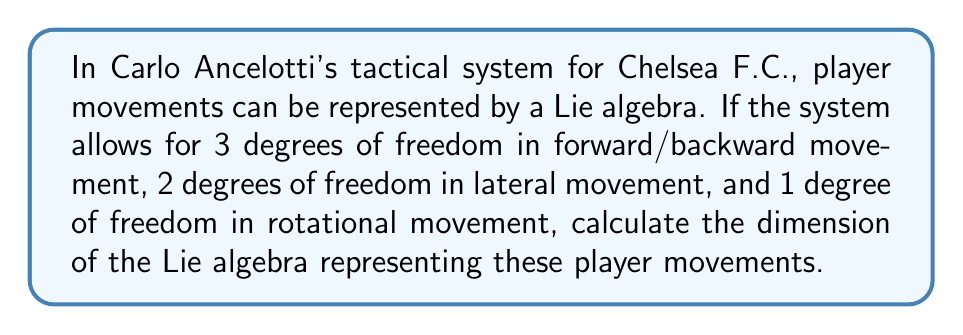Help me with this question. To solve this problem, we need to understand that the dimension of a Lie algebra is equal to the number of independent generators or basis elements. In this case, each degree of freedom corresponds to a generator in the Lie algebra.

Let's break down the degrees of freedom:

1. Forward/backward movement: 3 degrees of freedom
2. Lateral movement: 2 degrees of freedom
3. Rotational movement: 1 degree of freedom

The dimension of the Lie algebra is the sum of these independent generators:

$$ \text{dim}(\mathfrak{g}) = 3 + 2 + 1 $$

Where $\mathfrak{g}$ represents the Lie algebra of player movements in Ancelotti's tactical system.

Calculating:

$$ \text{dim}(\mathfrak{g}) = 3 + 2 + 1 = 6 $$

Therefore, the Lie algebra representing player movements in Ancelotti's tactical system has a dimension of 6.

This 6-dimensional Lie algebra could be thought of as similar to the special Euclidean group SE(3), which describes rigid body motions in 3D space. In this case, it's adapted to the specific constraints of Ancelotti's system for Chelsea F.C. players.
Answer: $$ \text{dim}(\mathfrak{g}) = 6 $$ 